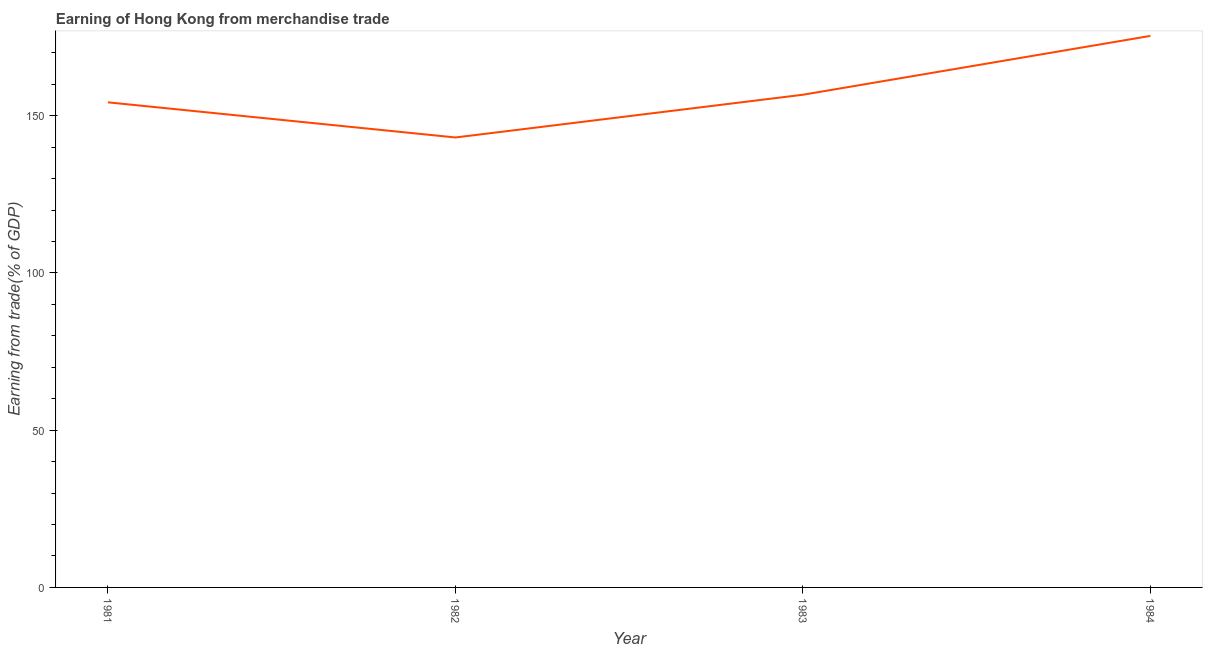What is the earning from merchandise trade in 1983?
Ensure brevity in your answer.  156.7. Across all years, what is the maximum earning from merchandise trade?
Provide a short and direct response. 175.41. Across all years, what is the minimum earning from merchandise trade?
Your answer should be very brief. 143.1. What is the sum of the earning from merchandise trade?
Provide a short and direct response. 629.48. What is the difference between the earning from merchandise trade in 1982 and 1984?
Offer a very short reply. -32.3. What is the average earning from merchandise trade per year?
Keep it short and to the point. 157.37. What is the median earning from merchandise trade?
Offer a terse response. 155.49. Do a majority of the years between 1981 and 1983 (inclusive) have earning from merchandise trade greater than 150 %?
Give a very brief answer. Yes. What is the ratio of the earning from merchandise trade in 1981 to that in 1984?
Offer a very short reply. 0.88. Is the earning from merchandise trade in 1982 less than that in 1984?
Your response must be concise. Yes. Is the difference between the earning from merchandise trade in 1981 and 1983 greater than the difference between any two years?
Offer a terse response. No. What is the difference between the highest and the second highest earning from merchandise trade?
Your response must be concise. 18.71. Is the sum of the earning from merchandise trade in 1981 and 1984 greater than the maximum earning from merchandise trade across all years?
Your answer should be very brief. Yes. What is the difference between the highest and the lowest earning from merchandise trade?
Your response must be concise. 32.3. In how many years, is the earning from merchandise trade greater than the average earning from merchandise trade taken over all years?
Keep it short and to the point. 1. Does the earning from merchandise trade monotonically increase over the years?
Your answer should be compact. No. How many years are there in the graph?
Offer a terse response. 4. What is the difference between two consecutive major ticks on the Y-axis?
Your answer should be very brief. 50. Does the graph contain any zero values?
Your response must be concise. No. Does the graph contain grids?
Make the answer very short. No. What is the title of the graph?
Offer a terse response. Earning of Hong Kong from merchandise trade. What is the label or title of the X-axis?
Provide a short and direct response. Year. What is the label or title of the Y-axis?
Your response must be concise. Earning from trade(% of GDP). What is the Earning from trade(% of GDP) in 1981?
Your response must be concise. 154.28. What is the Earning from trade(% of GDP) of 1982?
Ensure brevity in your answer.  143.1. What is the Earning from trade(% of GDP) of 1983?
Make the answer very short. 156.7. What is the Earning from trade(% of GDP) of 1984?
Offer a terse response. 175.41. What is the difference between the Earning from trade(% of GDP) in 1981 and 1982?
Provide a succinct answer. 11.17. What is the difference between the Earning from trade(% of GDP) in 1981 and 1983?
Keep it short and to the point. -2.42. What is the difference between the Earning from trade(% of GDP) in 1981 and 1984?
Keep it short and to the point. -21.13. What is the difference between the Earning from trade(% of GDP) in 1982 and 1983?
Your response must be concise. -13.59. What is the difference between the Earning from trade(% of GDP) in 1982 and 1984?
Your answer should be very brief. -32.3. What is the difference between the Earning from trade(% of GDP) in 1983 and 1984?
Your answer should be very brief. -18.71. What is the ratio of the Earning from trade(% of GDP) in 1981 to that in 1982?
Give a very brief answer. 1.08. What is the ratio of the Earning from trade(% of GDP) in 1981 to that in 1983?
Ensure brevity in your answer.  0.98. What is the ratio of the Earning from trade(% of GDP) in 1981 to that in 1984?
Offer a very short reply. 0.88. What is the ratio of the Earning from trade(% of GDP) in 1982 to that in 1983?
Provide a succinct answer. 0.91. What is the ratio of the Earning from trade(% of GDP) in 1982 to that in 1984?
Offer a very short reply. 0.82. What is the ratio of the Earning from trade(% of GDP) in 1983 to that in 1984?
Ensure brevity in your answer.  0.89. 